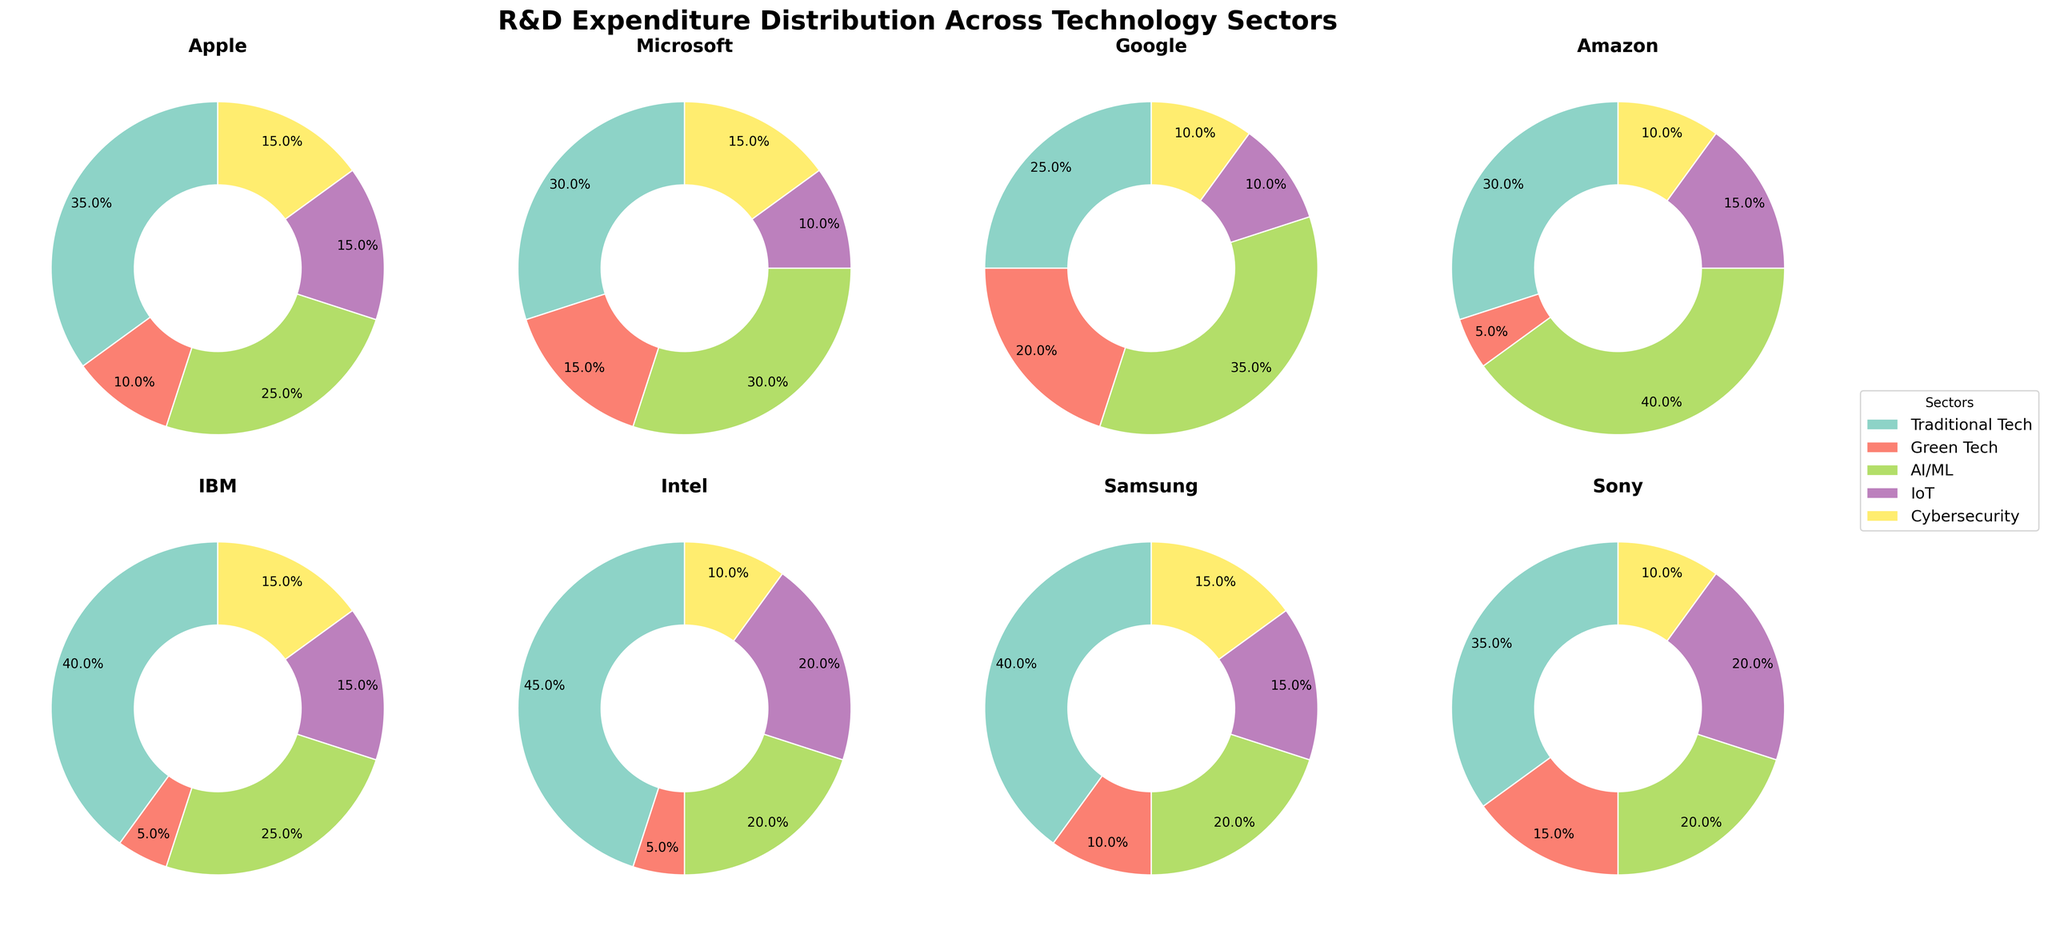Which company has the highest R&D expenditure in Traditional Tech? Samsung has the highest R&D expenditure in Traditional Tech, spending 45%. This is determined by looking at the pie segments labeled as 'Traditional Tech' across all subplots and identifying the company whose segment is the biggest.
Answer: Samsung What percentage of R&D does Amazon invest in Green Tech? The Amazon subplot shows that 5% of their R&D expenditure is dedicated to Green Tech, as seen in the pie chart slice labeled 'Green Tech.'
Answer: 5% Which sector does Google invest the most in? The Google subplot shows the largest pie chart slice is labeled 'AI/ML,' indicating that Google invests the most in AI/ML at 35%.
Answer: AI/ML Compare the R&D expenditure in IoT between Apple and Sony. Who spends more? Apple spends 15% of its R&D on IoT, while Sony spends 20%. By comparing the sizes of the 'IoT' slices in both the Apple and Sony subplots, it's clear that Sony spends more.
Answer: Sony What's the combined R&D expenditure in Green Tech for IBM and Intel? IBM spends 5% of R&D on Green Tech, and Intel spends 5% as well. Summing these values gives a combined expenditure of 5% + 5% = 10%.
Answer: 10% What's the difference in Cybersecurity R&D expenditure between Microsoft and Amazon? Microsoft spends 15% on Cybersecurity, while Amazon spends 10%. The difference is calculated by subtracting the smaller percentage from the larger one: 15% - 10% = 5%.
Answer: 5% Among the listed companies, which has the smallest investment in AI/ML? The pie chart slice for AI/ML is smallest in Intel's subplot, indicating that Intel has the smallest investment in this sector at 20%.
Answer: Intel Which company shows a more balanced R&D expenditure across all sectors? Google’s subplot shows similar-sized slices for each sector, indicating a more balanced expenditure with percentages relatively closer together compared to other companies.
Answer: Google 